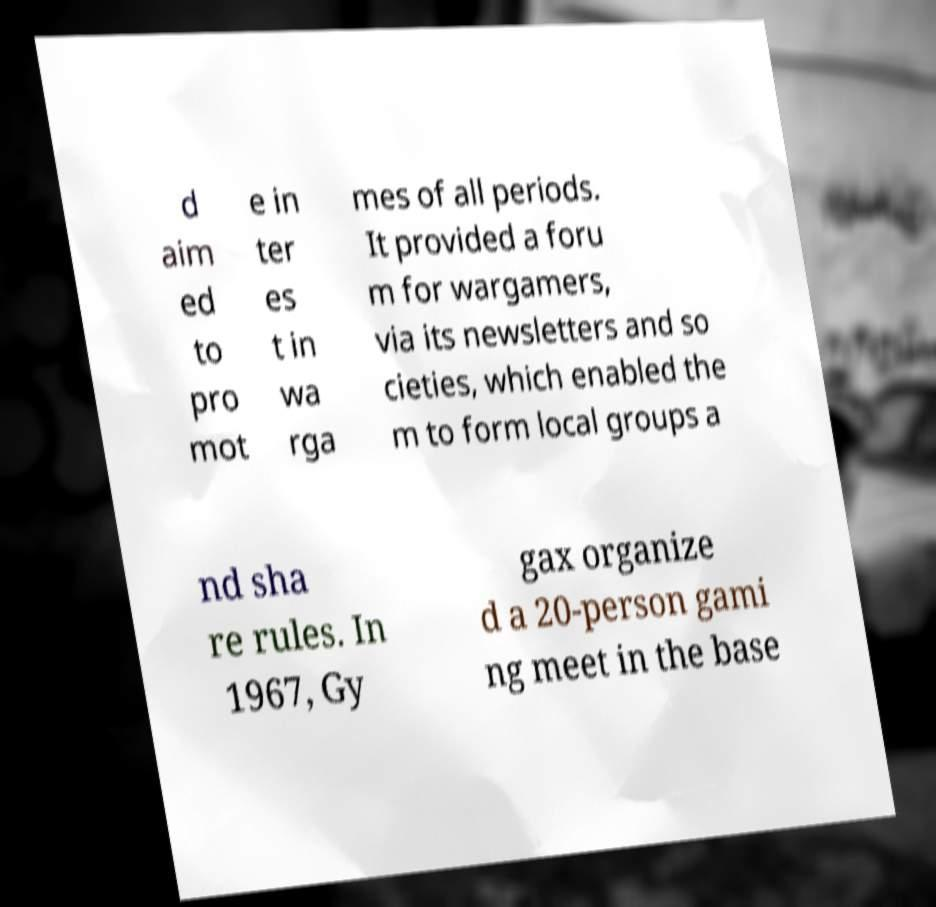Could you extract and type out the text from this image? d aim ed to pro mot e in ter es t in wa rga mes of all periods. It provided a foru m for wargamers, via its newsletters and so cieties, which enabled the m to form local groups a nd sha re rules. In 1967, Gy gax organize d a 20-person gami ng meet in the base 